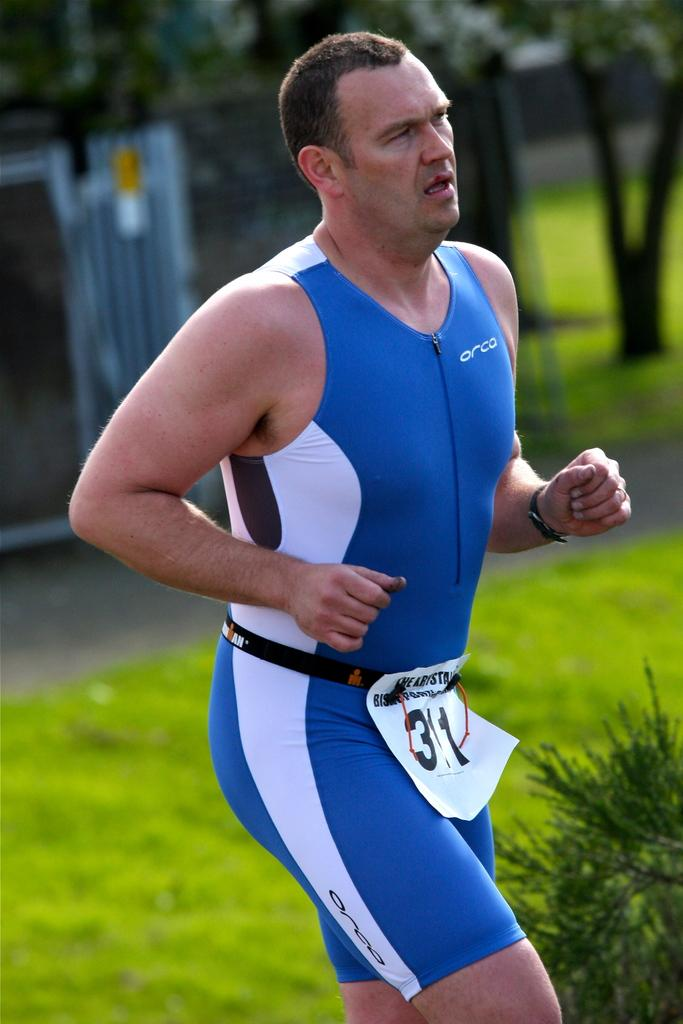Provide a one-sentence caption for the provided image. A man wearing a blue Orca running suit. 